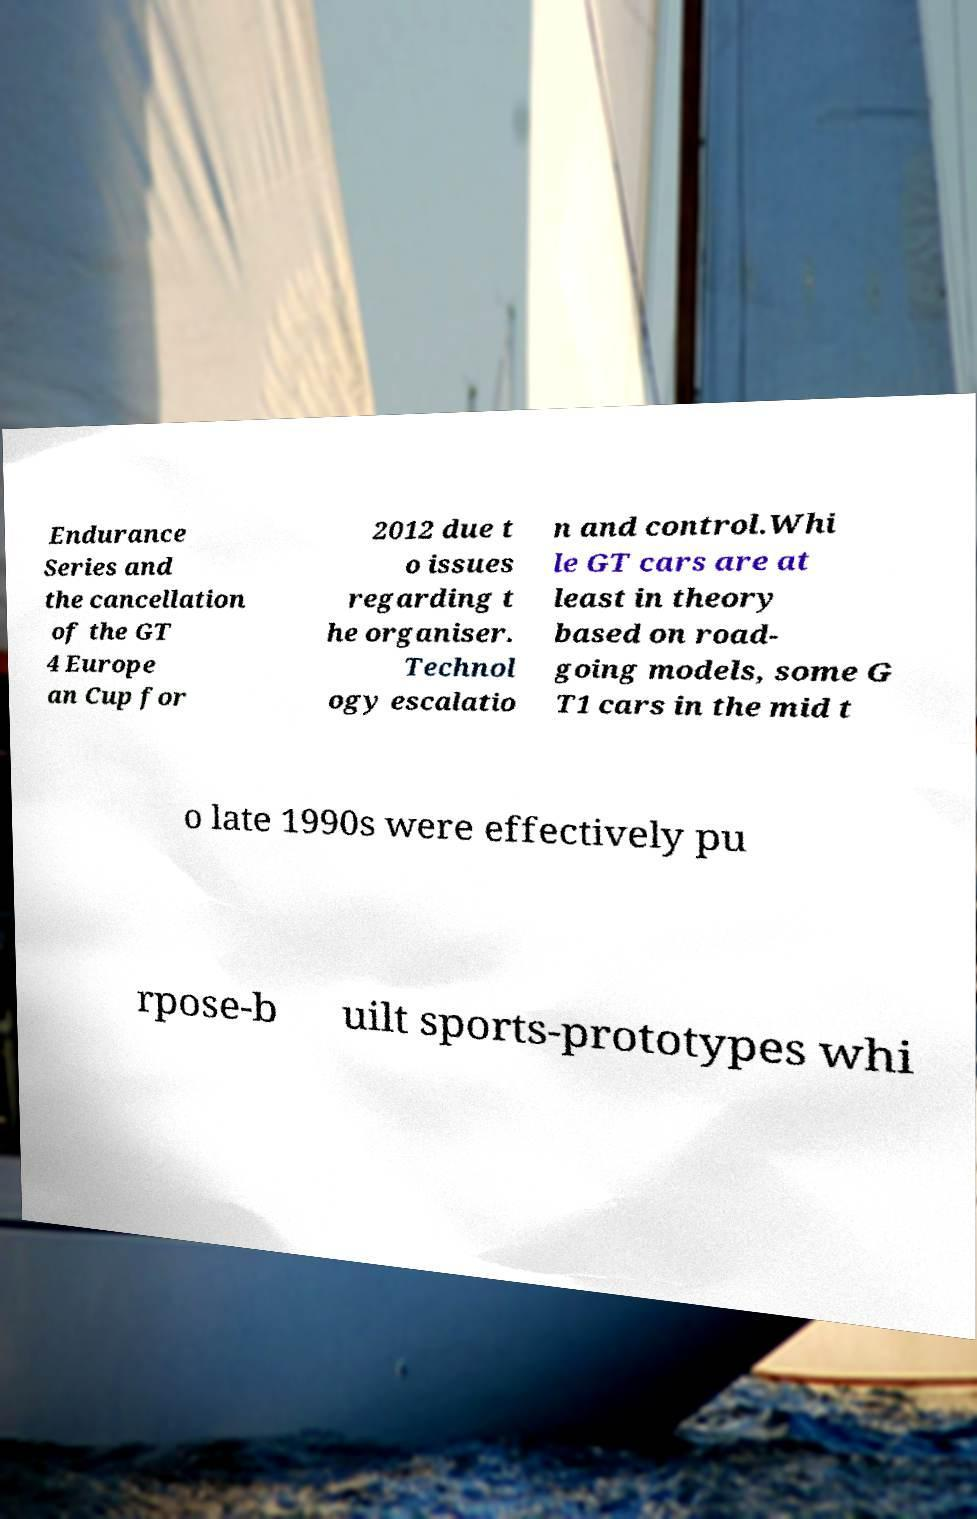Please read and relay the text visible in this image. What does it say? Endurance Series and the cancellation of the GT 4 Europe an Cup for 2012 due t o issues regarding t he organiser. Technol ogy escalatio n and control.Whi le GT cars are at least in theory based on road- going models, some G T1 cars in the mid t o late 1990s were effectively pu rpose-b uilt sports-prototypes whi 